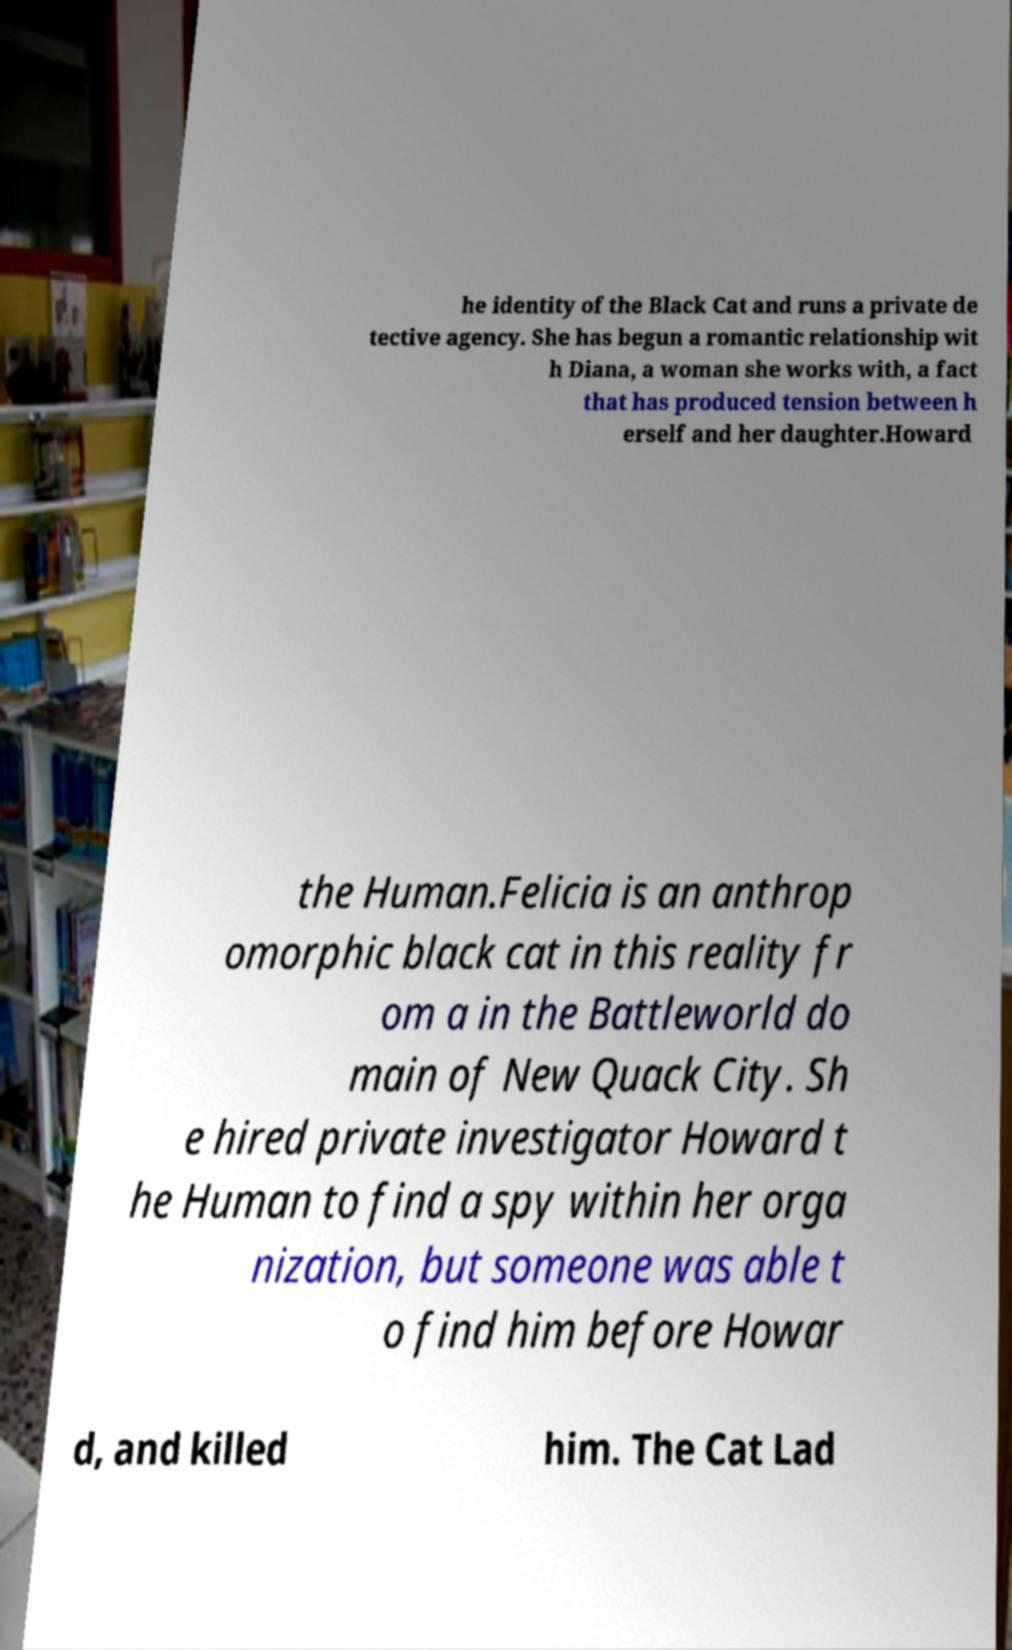Can you accurately transcribe the text from the provided image for me? he identity of the Black Cat and runs a private de tective agency. She has begun a romantic relationship wit h Diana, a woman she works with, a fact that has produced tension between h erself and her daughter.Howard the Human.Felicia is an anthrop omorphic black cat in this reality fr om a in the Battleworld do main of New Quack City. Sh e hired private investigator Howard t he Human to find a spy within her orga nization, but someone was able t o find him before Howar d, and killed him. The Cat Lad 